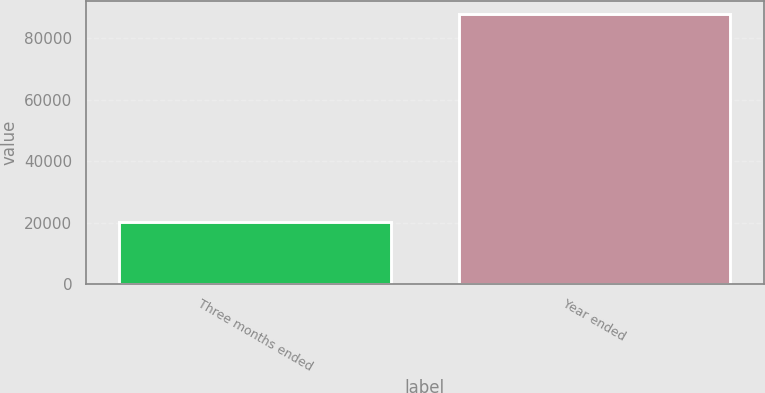Convert chart. <chart><loc_0><loc_0><loc_500><loc_500><bar_chart><fcel>Three months ended<fcel>Year ended<nl><fcel>20090<fcel>87885<nl></chart> 